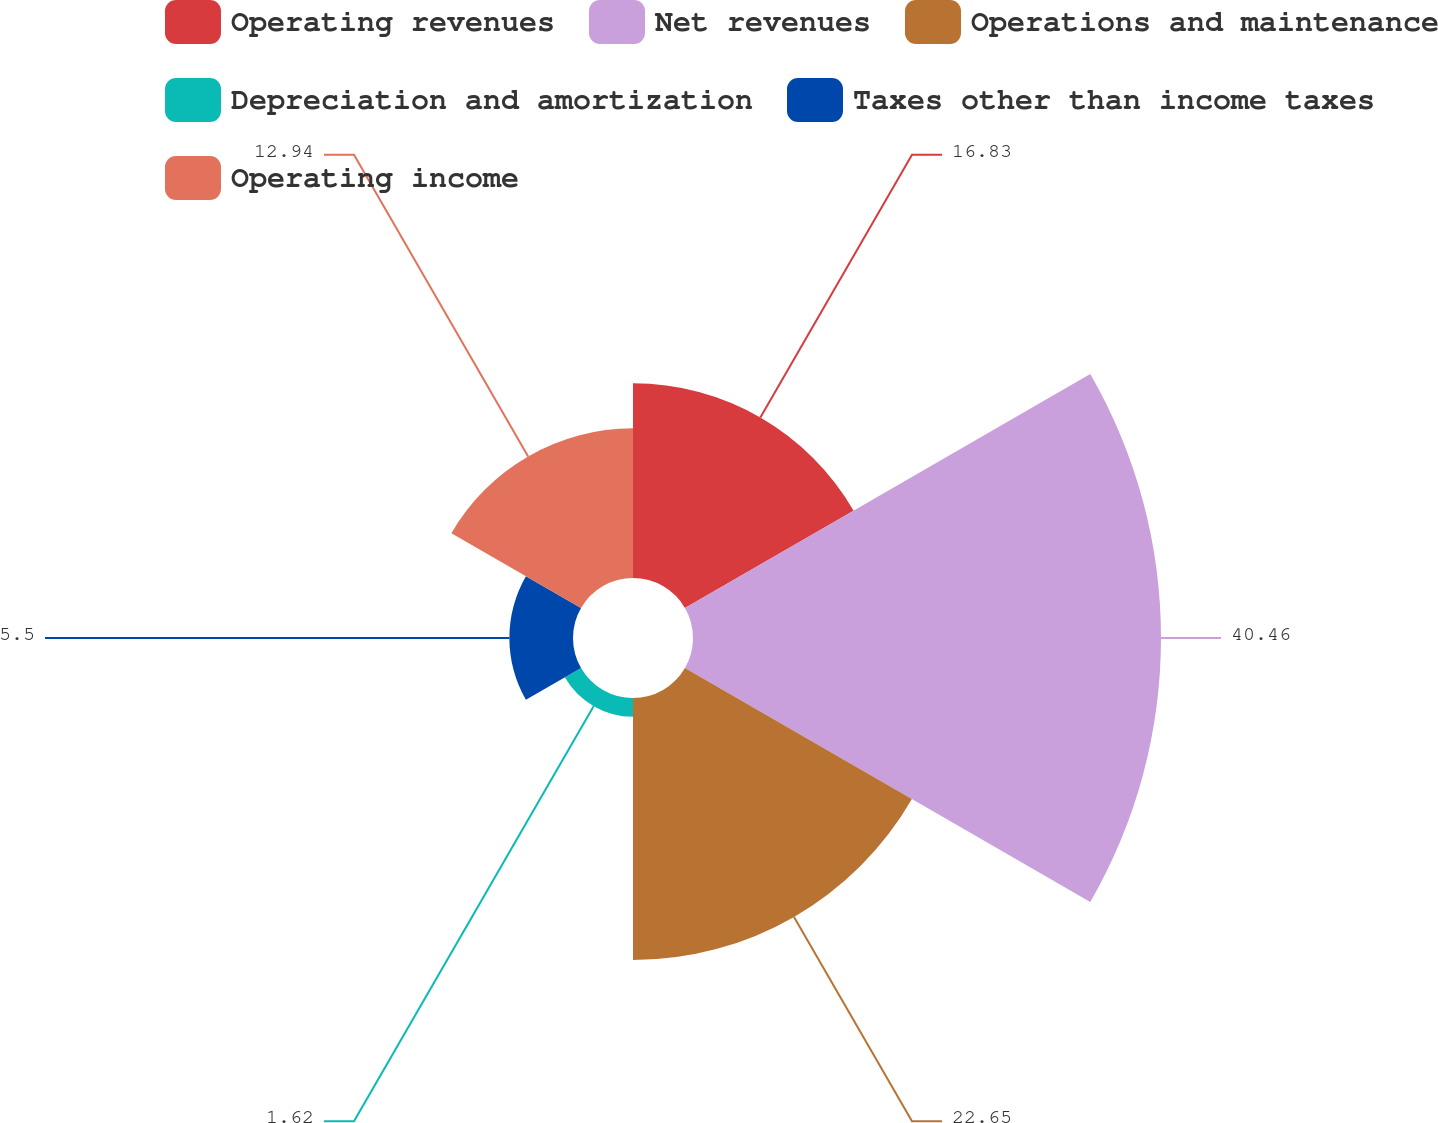Convert chart to OTSL. <chart><loc_0><loc_0><loc_500><loc_500><pie_chart><fcel>Operating revenues<fcel>Net revenues<fcel>Operations and maintenance<fcel>Depreciation and amortization<fcel>Taxes other than income taxes<fcel>Operating income<nl><fcel>16.83%<fcel>40.45%<fcel>22.65%<fcel>1.62%<fcel>5.5%<fcel>12.94%<nl></chart> 